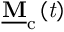<formula> <loc_0><loc_0><loc_500><loc_500>\underline { M } _ { c } \left ( t \right )</formula> 